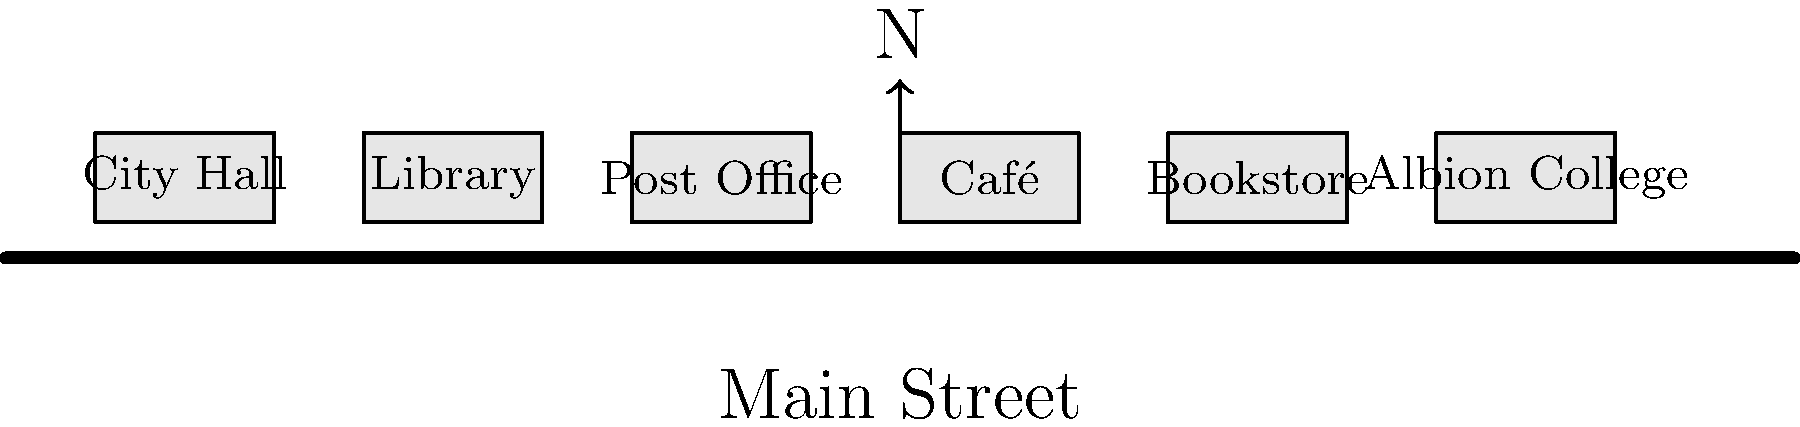Based on the simplified map of Albion's Main Street, which business is located between the Post Office and the Bookstore? To answer this question, let's follow these steps:

1. Observe the layout of the buildings on Main Street from left to right:
   - City Hall
   - Library
   - Post Office
   - Café
   - Bookstore
   - Albion College

2. Identify the position of the Post Office and the Bookstore:
   - The Post Office is the third building from the left.
   - The Bookstore is the fifth building from the left.

3. Look at the building located between the Post Office and the Bookstore:
   - We can see that the Café is situated between these two buildings.

4. Confirm that the Café is indeed the only business between the Post Office and the Bookstore.

Therefore, the business located between the Post Office and the Bookstore on Albion's Main Street is the Café.
Answer: Café 